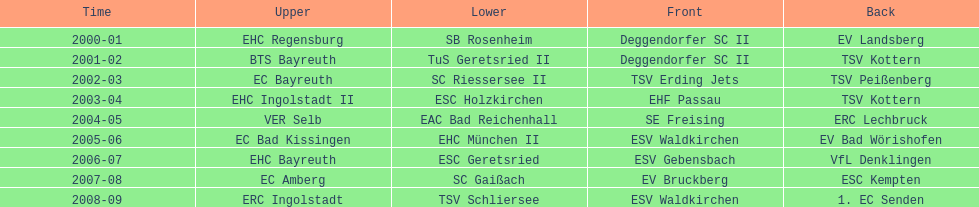Who won the season in the north before ec bayreuth did in 2002-03? BTS Bayreuth. 